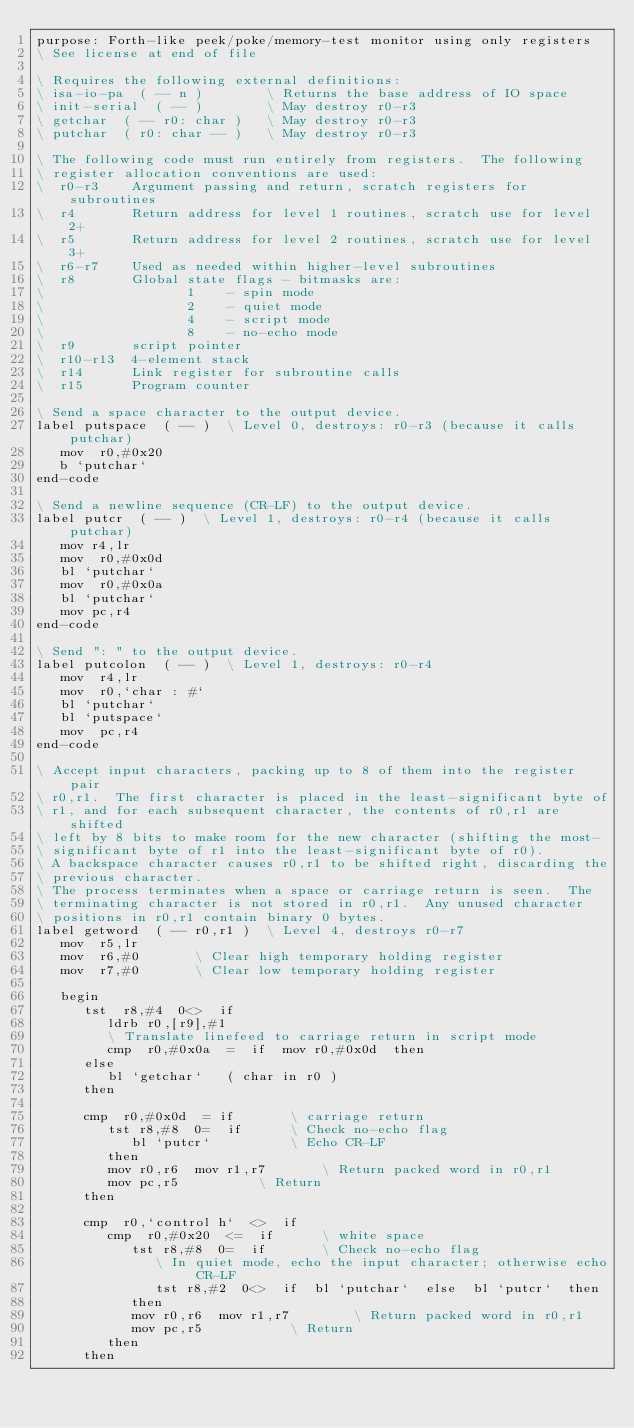<code> <loc_0><loc_0><loc_500><loc_500><_Forth_>purpose: Forth-like peek/poke/memory-test monitor using only registers
\ See license at end of file

\ Requires the following external definitions:
\ isa-io-pa  ( -- n )	     \ Returns the base address of IO space
\ init-serial  ( -- )        \ May destroy r0-r3
\ getchar  ( -- r0: char )   \ May destroy r0-r3
\ putchar  ( r0: char -- )   \ May destroy r0-r3

\ The following code must run entirely from registers.  The following
\ register allocation conventions are used:
\  r0-r3	Argument passing and return, scratch registers for subroutines
\  r4		Return address for level 1 routines, scratch use for level 2+
\  r5		Return address for level 2 routines, scratch use for level 3+
\  r6-r7	Used as needed within higher-level subroutines
\  r8		Global state flags - bitmasks are:
\                  1	- spin mode
\                  2	- quiet mode
\                  4	- script mode
\                  8	- no-echo mode
\  r9		script pointer
\  r10-r13	4-element stack
\  r14		Link register for subroutine calls
\  r15		Program counter

\ Send a space character to the output device.
label putspace  ( -- )  \ Level 0, destroys: r0-r3 (because it calls putchar)
   mov  r0,#0x20
   b `putchar`
end-code

\ Send a newline sequence (CR-LF) to the output device.
label putcr  ( -- )  \ Level 1, destroys: r0-r4 (because it calls putchar)
   mov r4,lr
   mov  r0,#0x0d
   bl `putchar`
   mov  r0,#0x0a
   bl `putchar`
   mov pc,r4
end-code

\ Send ": " to the output device.
label putcolon  ( -- )  \ Level 1, destroys: r0-r4
   mov  r4,lr
   mov  r0,`char : #`
   bl `putchar`
   bl `putspace`
   mov  pc,r4
end-code

\ Accept input characters, packing up to 8 of them into the register pair
\ r0,r1.  The first character is placed in the least-significant byte of
\ r1, and for each subsequent character, the contents of r0,r1 are shifted
\ left by 8 bits to make room for the new character (shifting the most-
\ significant byte of r1 into the least-significant byte of r0).
\ A backspace character causes r0,r1 to be shifted right, discarding the
\ previous character.
\ The process terminates when a space or carriage return is seen.  The
\ terminating character is not stored in r0,r1.  Any unused character
\ positions in r0,r1 contain binary 0 bytes.
label getword  ( -- r0,r1 )  \ Level 4, destroys r0-r7
   mov  r5,lr
   mov  r6,#0		\ Clear high temporary holding register
   mov  r7,#0		\ Clear low temporary holding register

   begin
      tst  r8,#4  0<>  if
         ldrb r0,[r9],#1
         \ Translate linefeed to carriage return in script mode
         cmp  r0,#0x0a  =  if  mov r0,#0x0d  then
      else
         bl `getchar`   ( char in r0 )
      then

      cmp  r0,#0x0d  = if		\ carriage return
         tst r8,#8  0=  if		\ Check no-echo flag
            bl `putcr`			\ Echo CR-LF
         then
         mov r0,r6  mov r1,r7		\ Return packed word in r0,r1
         mov pc,r5			\ Return
      then

      cmp  r0,`control h`  <>  if
         cmp  r0,#0x20  <=  if		\ white space
            tst r8,#8  0=  if		\ Check no-echo flag
               \ In quiet mode, echo the input character; otherwise echo CR-LF
               tst r8,#2  0<>  if  bl `putchar`  else  bl `putcr`  then
            then
            mov r0,r6  mov r1,r7		\ Return packed word in r0,r1
            mov pc,r5			\ Return
         then
      then
</code> 